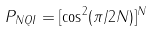Convert formula to latex. <formula><loc_0><loc_0><loc_500><loc_500>P _ { N Q I } = [ \cos ^ { 2 } ( \pi / 2 N ) ] ^ { N }</formula> 